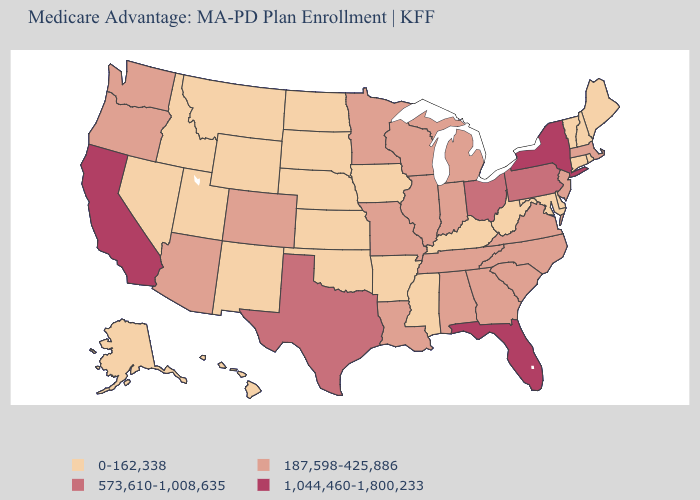Does the map have missing data?
Write a very short answer. No. Name the states that have a value in the range 573,610-1,008,635?
Short answer required. Ohio, Pennsylvania, Texas. Among the states that border South Dakota , which have the lowest value?
Keep it brief. Iowa, Montana, North Dakota, Nebraska, Wyoming. Which states hav the highest value in the MidWest?
Give a very brief answer. Ohio. Name the states that have a value in the range 0-162,338?
Keep it brief. Alaska, Arkansas, Connecticut, Delaware, Hawaii, Iowa, Idaho, Kansas, Kentucky, Maryland, Maine, Mississippi, Montana, North Dakota, Nebraska, New Hampshire, New Mexico, Nevada, Oklahoma, Rhode Island, South Dakota, Utah, Vermont, West Virginia, Wyoming. Among the states that border Washington , which have the lowest value?
Give a very brief answer. Idaho. What is the value of Colorado?
Quick response, please. 187,598-425,886. Does Massachusetts have a higher value than Tennessee?
Short answer required. No. Does Nevada have the lowest value in the USA?
Answer briefly. Yes. Does the map have missing data?
Give a very brief answer. No. Name the states that have a value in the range 573,610-1,008,635?
Write a very short answer. Ohio, Pennsylvania, Texas. What is the value of Delaware?
Write a very short answer. 0-162,338. What is the value of Florida?
Concise answer only. 1,044,460-1,800,233. What is the highest value in the Northeast ?
Keep it brief. 1,044,460-1,800,233. What is the highest value in states that border Pennsylvania?
Give a very brief answer. 1,044,460-1,800,233. 